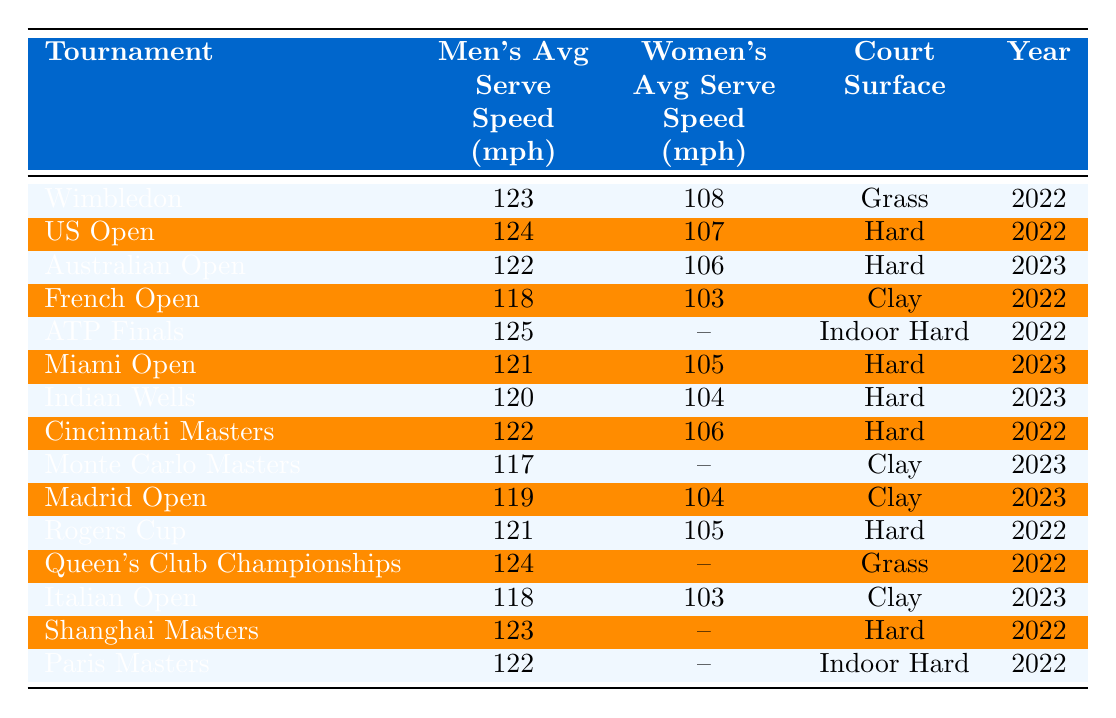What is the average men's serve speed at the US Open? Look at the "US Open" row under the "Men's Avg Serve Speed (mph)" column. The value there is 124 mph.
Answer: 124 mph Which tournament has the highest average women's serve speed? The highest value in the "Women's Avg Serve Speed (mph)" column is 108 mph from the "Wimbledon" row.
Answer: Wimbledon What is the average men's serve speed across all tournaments listed for 2022? Sum all the men's average serve speeds for 2022: 123 + 124 + 118 + 125 + 121 + 122 + 117 + 124 + 123 + 122 = 1251. Divide by the number of tournaments, which is 10: 1251/10 = 125.1 mph.
Answer: 125.1 mph Is there any tournament where the women's average serve speed is not listed? Yes, for several tournaments such as "ATP Finals," "Monte Carlo Masters," "Queen's Club Championships," and others, there are null values for the women's average serve speed.
Answer: Yes Which surface has the highest average men's serve speed? The average men's serve speeds can be compared: Grass (123 mph), Hard (123 mph), Clay (119 mph), Indoor Hard (122 mph). The maximum is 125 mph from "ATP Finals" on Indoor Hard.
Answer: Indoor Hard What is the difference in average men's serve speed between Wimbledon and the French Open? The men's serve speed at Wimbledon is 123 mph and at the French Open is 118 mph. The difference is 123 - 118 = 5 mph.
Answer: 5 mph What proportion of tournaments held on Hard courts have a men's average serve speed of over 120 mph? The hard court tournaments listed are US Open (124 mph), Australian Open (122 mph), Miami Open (121 mph), Indian Wells (120 mph), Cincinnati Masters (122 mph), and Rogers Cup (121 mph). Out of these six, four have speeds over 120 mph (US Open, Australian Open, Miami Open, Cincinnati Masters). The proportion is 4/6, which simplifies to 2/3.
Answer: 2/3 Identify the men's average serve speed for the tournament that takes place on clay and is the most recent. The most recent clay tournament is "Monte Carlo Masters" from 2023, which has a men's average serve speed of 117 mph.
Answer: 117 mph What trend can be inferred about women's serve speeds compared to men's serve speeds in this dataset? Generally, men's average serve speeds are higher than women's serve speeds, which is reflected in every row where both are present. The highest men's average speed is 125 mph (ATP Finals) compared to the highest women's speed of 108 mph (Wimbledon).
Answer: Men's serve speeds are higher Is it true that the average serve speed for men is always greater than that for women in all tournaments listed? Yes, in every tournament where both men's and women's averages are listed, the men's speed is higher than the women's.
Answer: Yes 